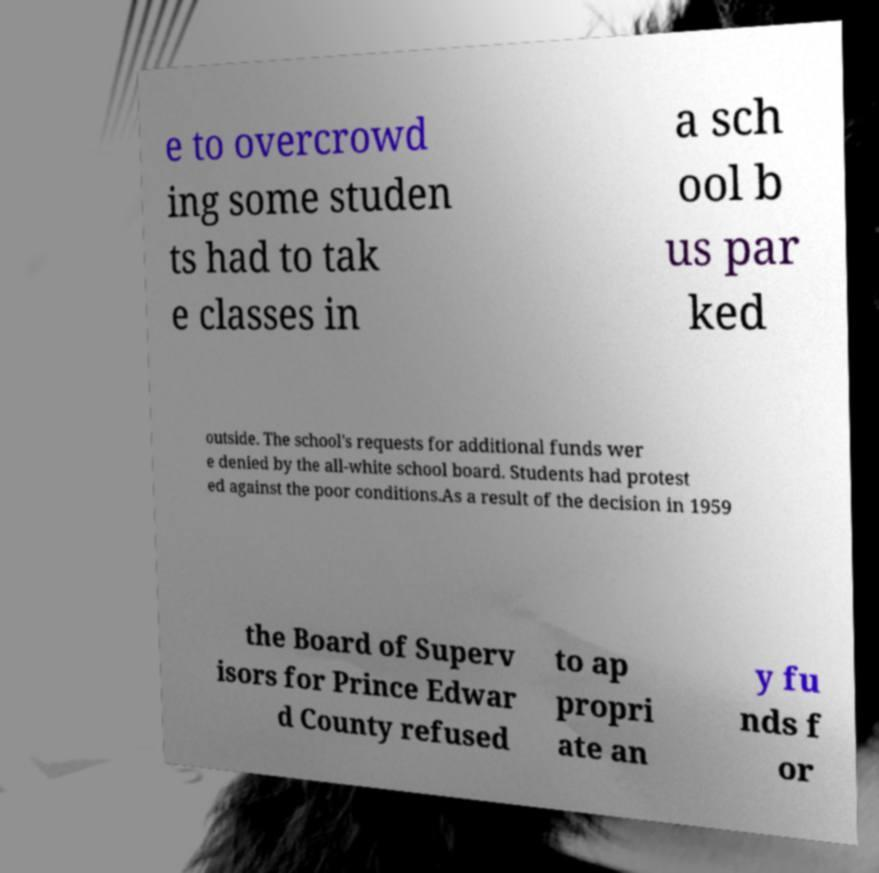Could you assist in decoding the text presented in this image and type it out clearly? e to overcrowd ing some studen ts had to tak e classes in a sch ool b us par ked outside. The school's requests for additional funds wer e denied by the all-white school board. Students had protest ed against the poor conditions.As a result of the decision in 1959 the Board of Superv isors for Prince Edwar d County refused to ap propri ate an y fu nds f or 